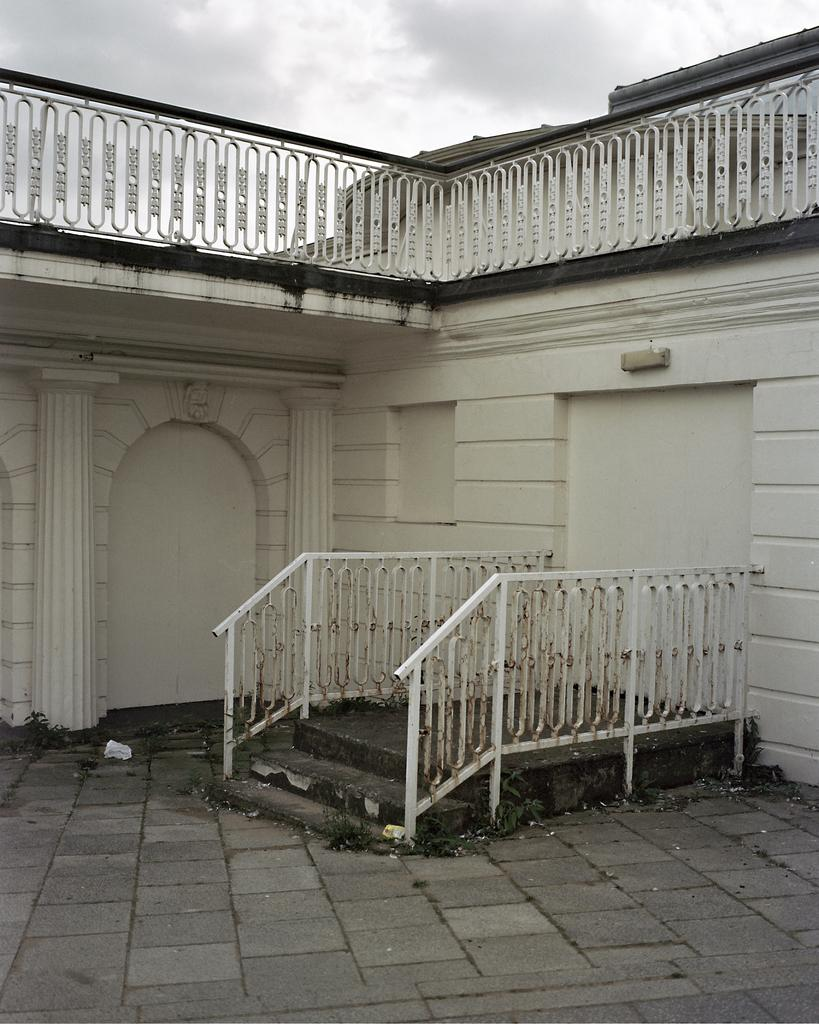What type of structure is visible in the picture? There is a house in the picture. What can be seen near the house? There is a railing and steps in the picture. What is visible at the top of the picture? The sky is visible at the top of the picture. Can you observe any quicksand in the picture? There is no mention of quicksand or any hazardous conditions in the provided facts, so we cannot determine if there is any quicksand present in the image. 